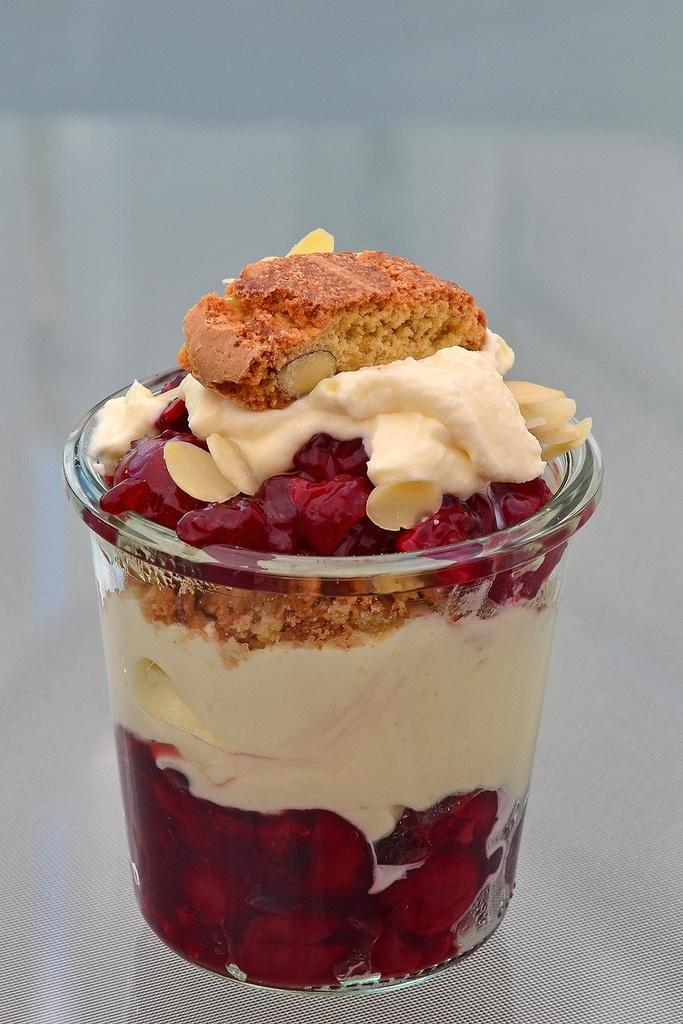What type of dessert is in the cup in the image? There is ice cream in a cup in the image. Where is the ice cream located? The ice cream is present on a table. Can you describe the container holding the ice cream? The ice cream is in a cup. What is the weight of the ice cream in the image? The weight of the ice cream cannot be determined from the image alone, as it does not provide any information about the size or volume of the ice cream. 